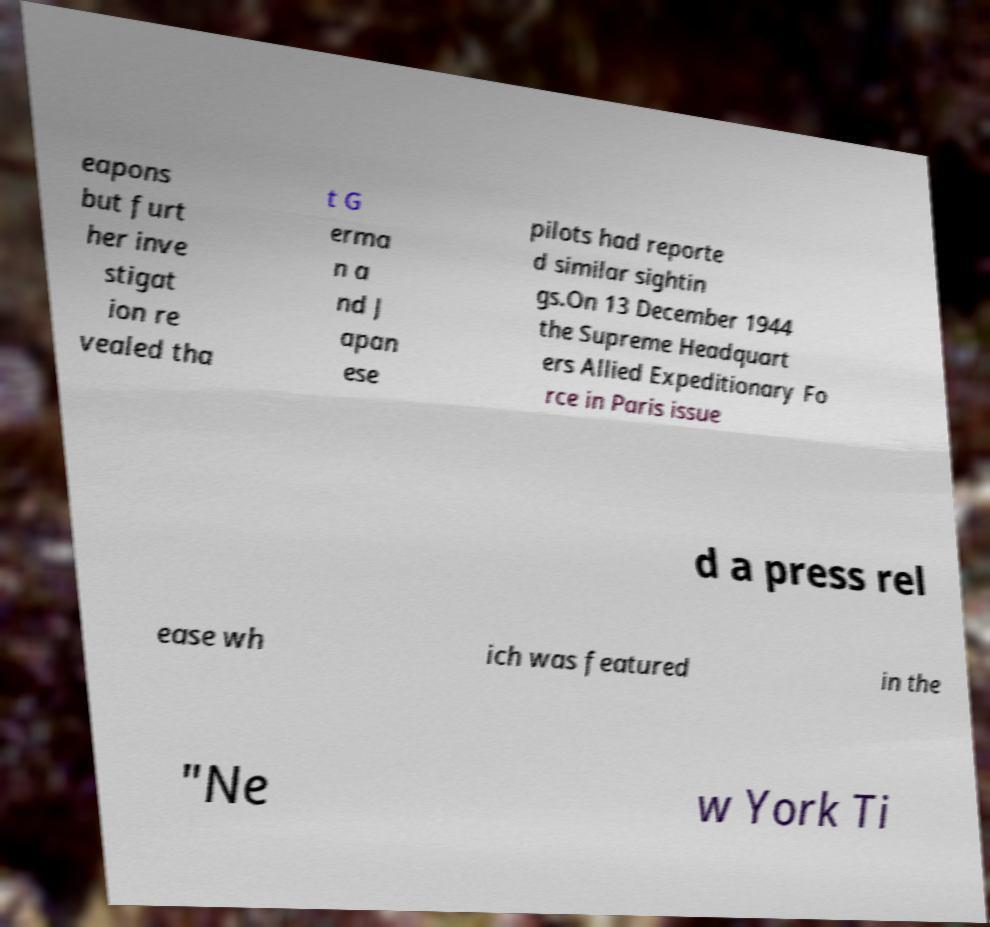Can you accurately transcribe the text from the provided image for me? eapons but furt her inve stigat ion re vealed tha t G erma n a nd J apan ese pilots had reporte d similar sightin gs.On 13 December 1944 the Supreme Headquart ers Allied Expeditionary Fo rce in Paris issue d a press rel ease wh ich was featured in the "Ne w York Ti 